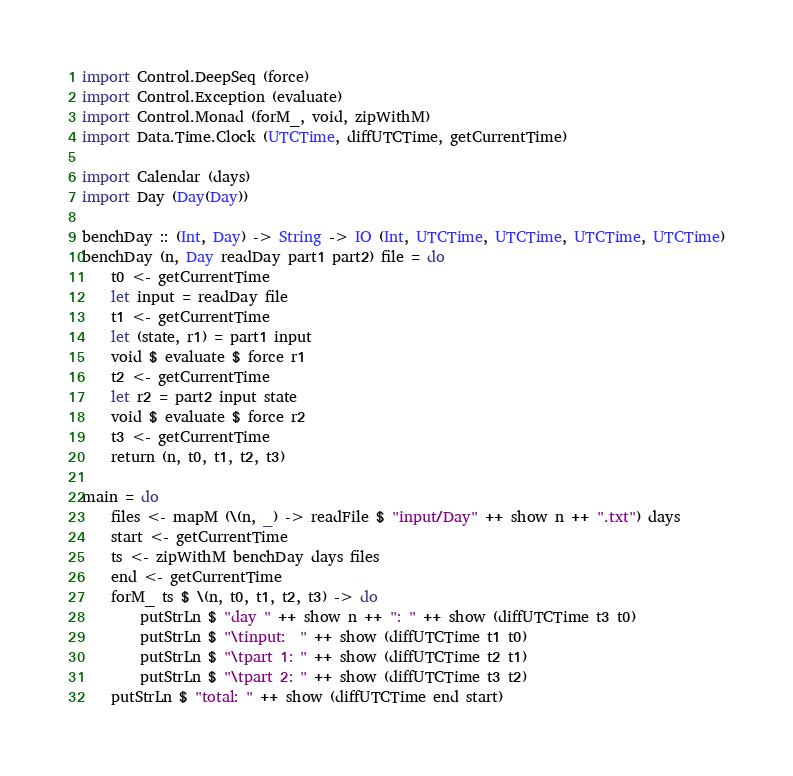Convert code to text. <code><loc_0><loc_0><loc_500><loc_500><_Haskell_>import Control.DeepSeq (force)
import Control.Exception (evaluate)
import Control.Monad (forM_, void, zipWithM)
import Data.Time.Clock (UTCTime, diffUTCTime, getCurrentTime)

import Calendar (days)
import Day (Day(Day))

benchDay :: (Int, Day) -> String -> IO (Int, UTCTime, UTCTime, UTCTime, UTCTime)
benchDay (n, Day readDay part1 part2) file = do
    t0 <- getCurrentTime
    let input = readDay file
    t1 <- getCurrentTime
    let (state, r1) = part1 input
    void $ evaluate $ force r1
    t2 <- getCurrentTime
    let r2 = part2 input state
    void $ evaluate $ force r2
    t3 <- getCurrentTime
    return (n, t0, t1, t2, t3)

main = do
    files <- mapM (\(n, _) -> readFile $ "input/Day" ++ show n ++ ".txt") days
    start <- getCurrentTime
    ts <- zipWithM benchDay days files
    end <- getCurrentTime
    forM_ ts $ \(n, t0, t1, t2, t3) -> do
        putStrLn $ "day " ++ show n ++ ": " ++ show (diffUTCTime t3 t0)
        putStrLn $ "\tinput:  " ++ show (diffUTCTime t1 t0)
        putStrLn $ "\tpart 1: " ++ show (diffUTCTime t2 t1)
        putStrLn $ "\tpart 2: " ++ show (diffUTCTime t3 t2)
    putStrLn $ "total: " ++ show (diffUTCTime end start)
</code> 